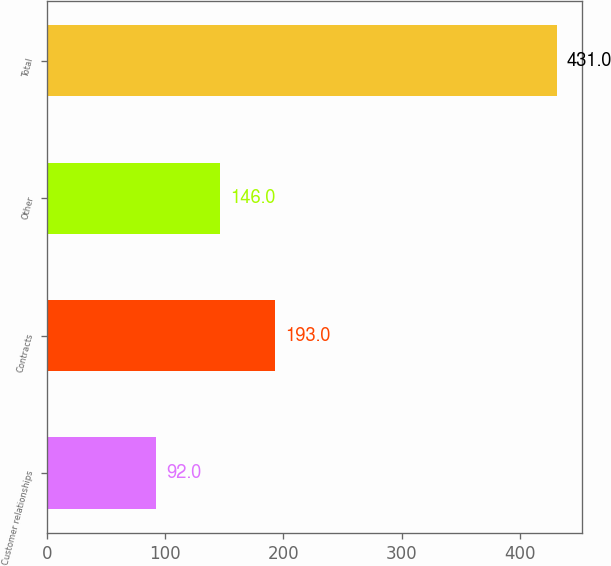<chart> <loc_0><loc_0><loc_500><loc_500><bar_chart><fcel>Customer relationships<fcel>Contracts<fcel>Other<fcel>Total<nl><fcel>92<fcel>193<fcel>146<fcel>431<nl></chart> 